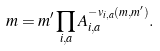<formula> <loc_0><loc_0><loc_500><loc_500>m = m ^ { \prime } \prod _ { i , a } A _ { i , a } ^ { - v _ { i , a } ( m , m ^ { \prime } ) } .</formula> 